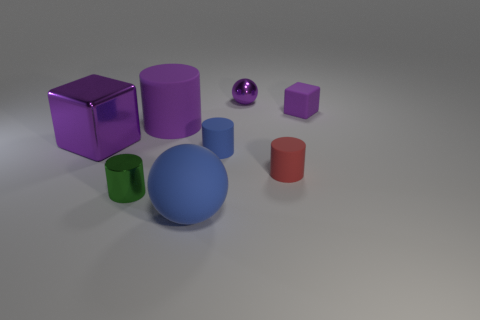Subtract all green cylinders. How many cylinders are left? 3 Subtract 1 cylinders. How many cylinders are left? 3 Subtract all brown cylinders. Subtract all yellow blocks. How many cylinders are left? 4 Add 1 blue cylinders. How many objects exist? 9 Subtract all cubes. How many objects are left? 6 Add 8 small brown metal blocks. How many small brown metal blocks exist? 8 Subtract 0 gray cylinders. How many objects are left? 8 Subtract all small green metallic cylinders. Subtract all spheres. How many objects are left? 5 Add 8 large cylinders. How many large cylinders are left? 9 